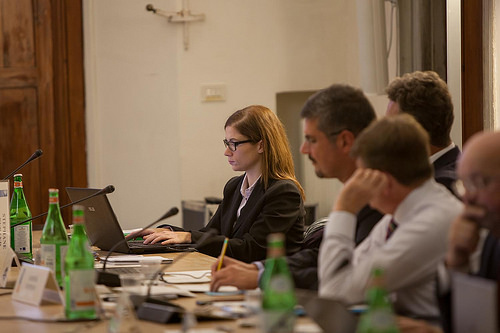<image>
Is the eyeglasses on the man? No. The eyeglasses is not positioned on the man. They may be near each other, but the eyeglasses is not supported by or resting on top of the man. 